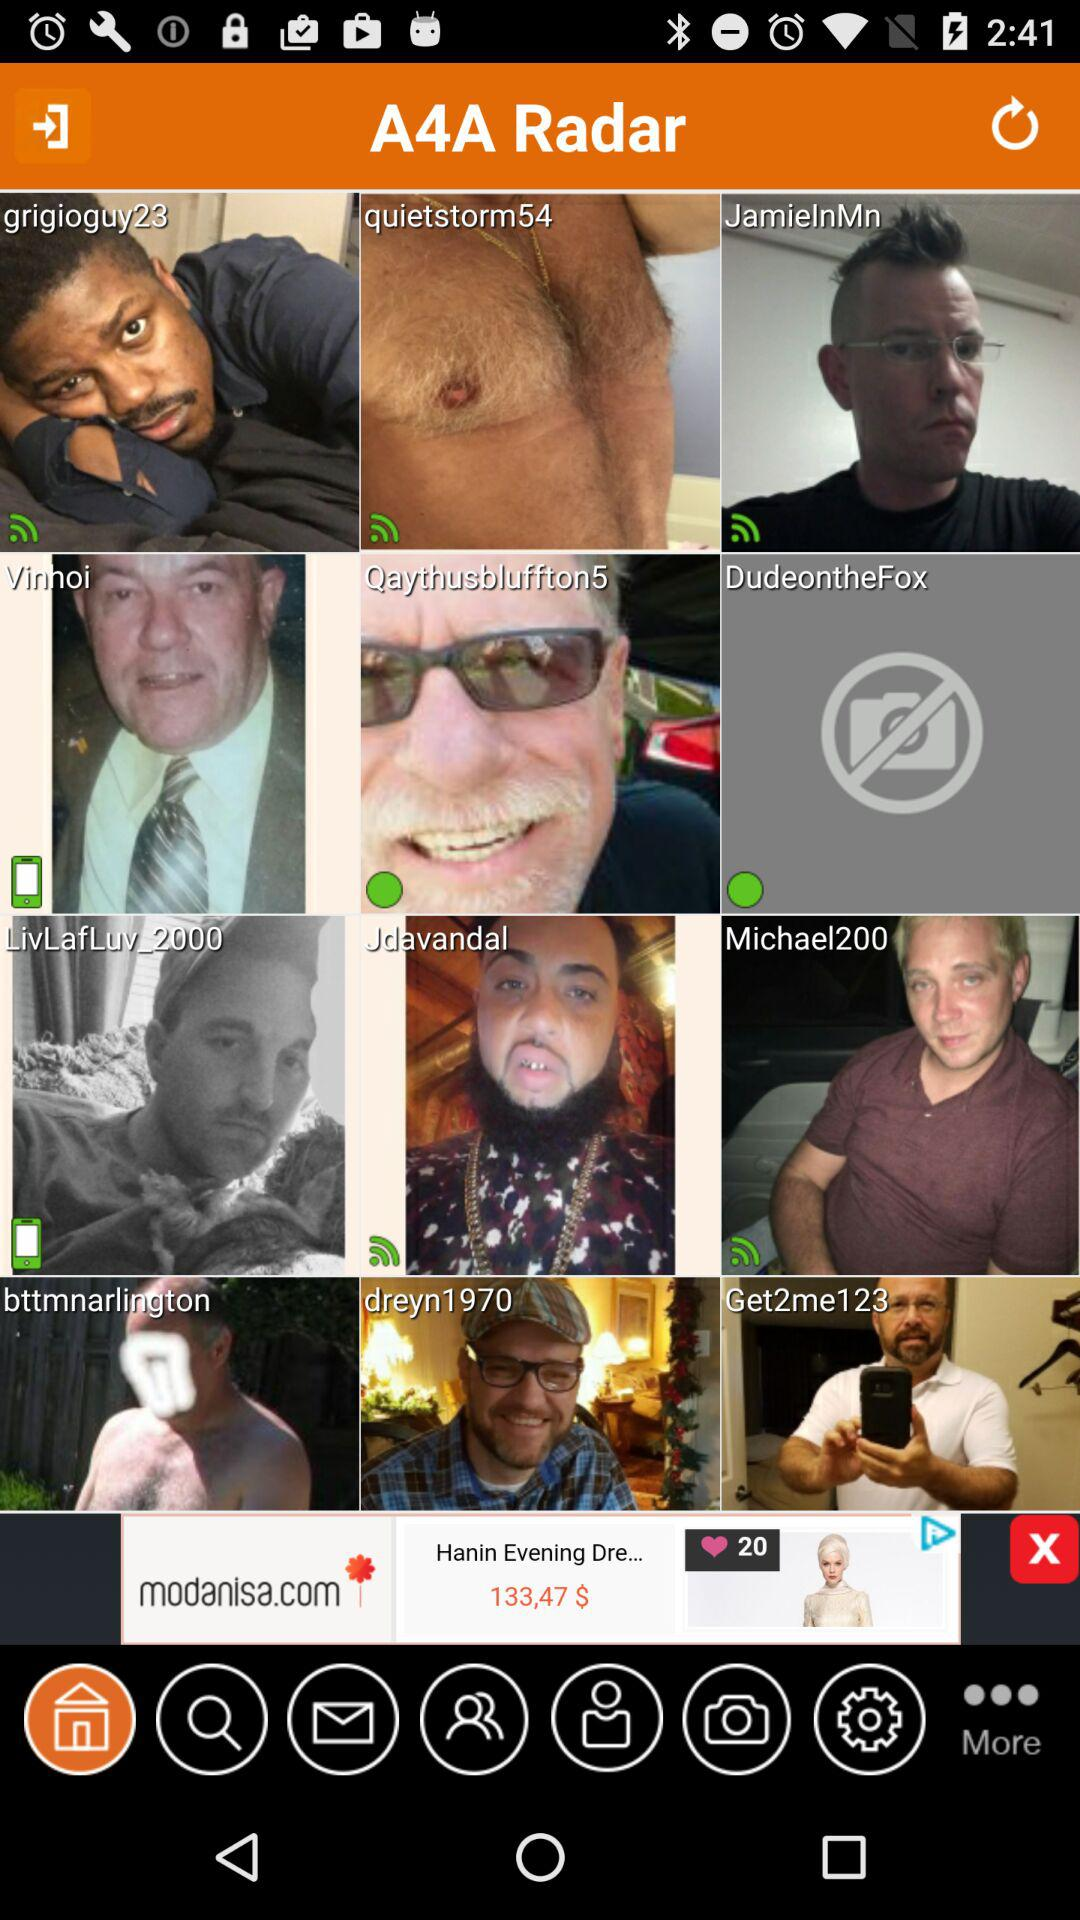Who is online? The names of the people who are online are "Qaythusbluffton5" and "DudeontheFox". 